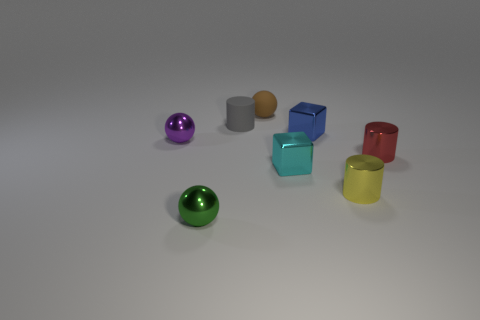Subtract all yellow blocks. Subtract all blue balls. How many blocks are left? 2 Add 1 blue balls. How many objects exist? 9 Subtract all cubes. How many objects are left? 6 Add 7 small matte balls. How many small matte balls are left? 8 Add 3 small red balls. How many small red balls exist? 3 Subtract 0 gray cubes. How many objects are left? 8 Subtract all spheres. Subtract all small gray cylinders. How many objects are left? 4 